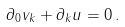Convert formula to latex. <formula><loc_0><loc_0><loc_500><loc_500>\partial _ { 0 } v _ { k } + \partial _ { k } u = 0 \, .</formula> 